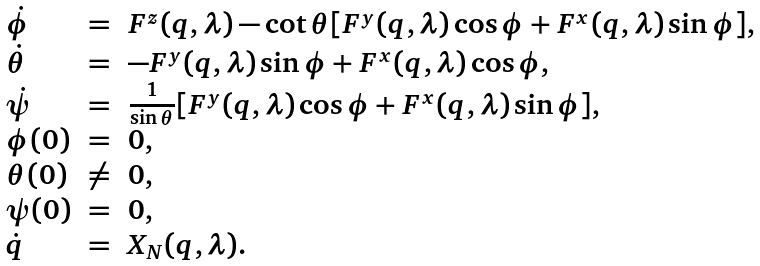<formula> <loc_0><loc_0><loc_500><loc_500>\begin{array} { l l l } \dot { \phi } & = & F ^ { z } ( q , \lambda ) - \cot \theta [ F ^ { y } ( q , \lambda ) \cos \phi + F ^ { x } ( q , \lambda ) \sin \phi ] , \\ \dot { \theta } & = & - F ^ { y } ( q , \lambda ) \sin \phi + F ^ { x } ( q , \lambda ) \cos \phi , \\ \dot { \psi } & = & \frac { 1 } { \sin \theta } [ F ^ { y } ( q , \lambda ) \cos \phi + F ^ { x } ( q , \lambda ) \sin \phi ] , \\ \phi ( 0 ) & = & 0 , \\ \theta ( 0 ) & \neq & 0 , \\ \psi ( 0 ) & = & 0 , \\ \dot { q } & = & X _ { N } ( q , \lambda ) . \end{array}</formula> 